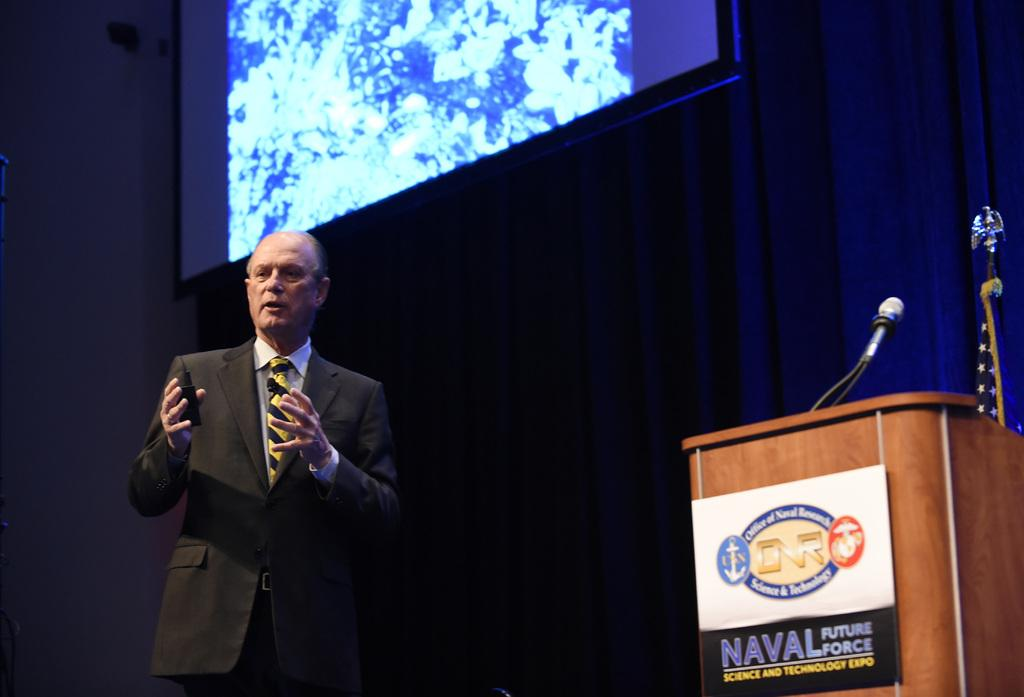What is located on the right side of the image? There is a podium on the right side of the image. What can be seen on or near the podium? There is a microphone in the image. What other objects are present on the right side of the image? There are other objects on the right side of the image, but their specific details are not mentioned in the facts. What is the person on the left side of the image doing? There is a person talking on the left side of the image. What is the purpose of the projector screen at the top of the image? The projector screen at the top of the image is likely used for displaying visual aids during the presentation or event. What type of curtain is present in the middle of the image? There is a blue curtain in the middle of the image. How many mice are hiding behind the blue curtain in the image? There is no mention of mice in the image, so it is impossible to determine their presence or quantity. What type of peace is being discussed by the person on the left side of the image? The image does not provide any information about the topic of discussion, so it is impossible to determine if peace is being discussed. 